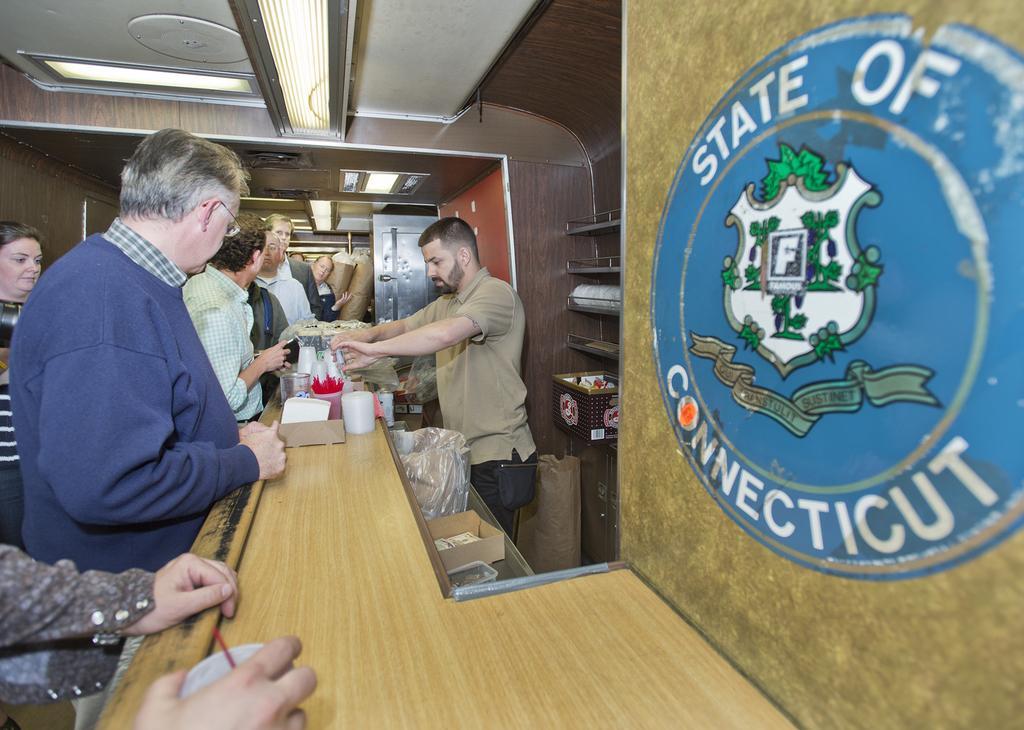Could you give a brief overview of what you see in this image? In the center of the image we can see a man standing and holding a glass in his hand, before him there is a counter table and we can see glasses, mugs and some things placed on the table. On the left there are people standing. In the background there is a wall, door and lights. On the right we can see an emblem on the wall. 